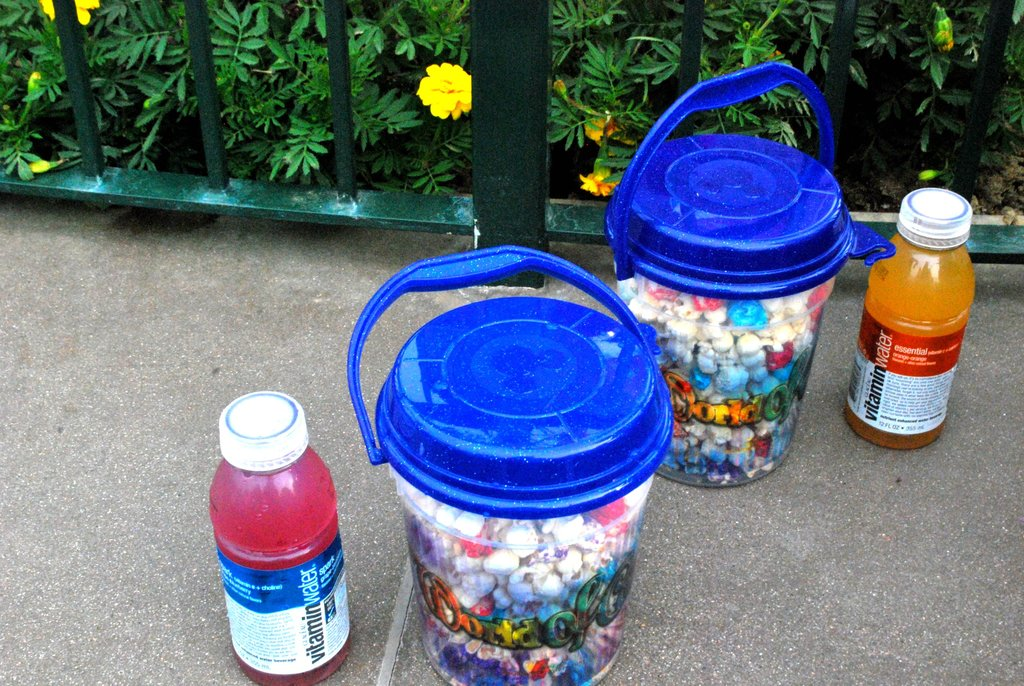Provide a one-sentence caption for the provided image. Two bottles of flavored vitamin water placed next to two large buckets filled with colorful bottle caps, suggesting a recycling or collection effort. 